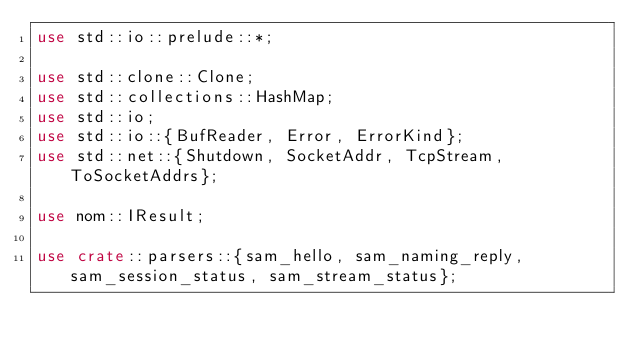<code> <loc_0><loc_0><loc_500><loc_500><_Rust_>use std::io::prelude::*;

use std::clone::Clone;
use std::collections::HashMap;
use std::io;
use std::io::{BufReader, Error, ErrorKind};
use std::net::{Shutdown, SocketAddr, TcpStream, ToSocketAddrs};

use nom::IResult;

use crate::parsers::{sam_hello, sam_naming_reply, sam_session_status, sam_stream_status};
</code> 